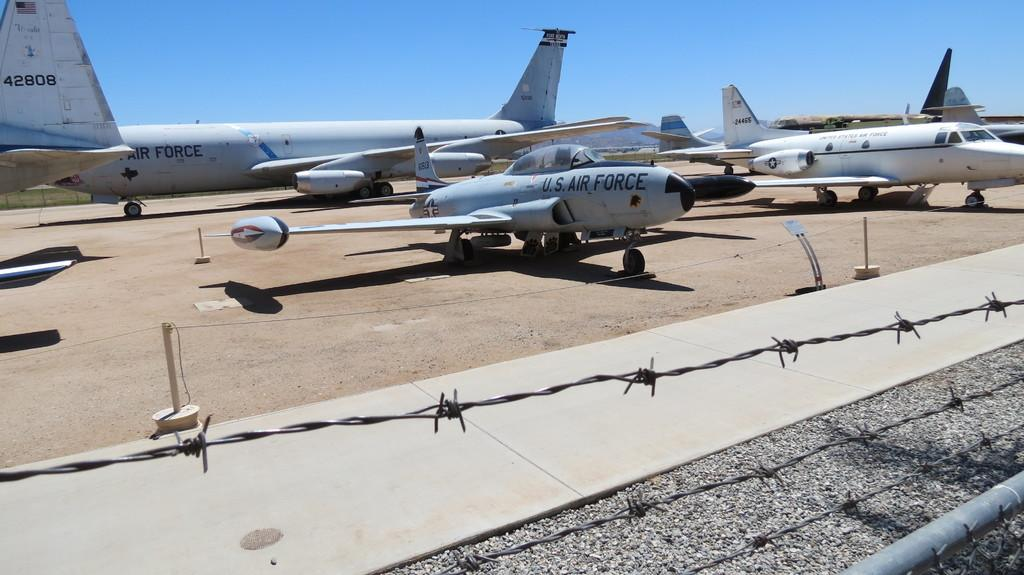Provide a one-sentence caption for the provided image. Several US AIr Force planes are parked behind barbed wire. 